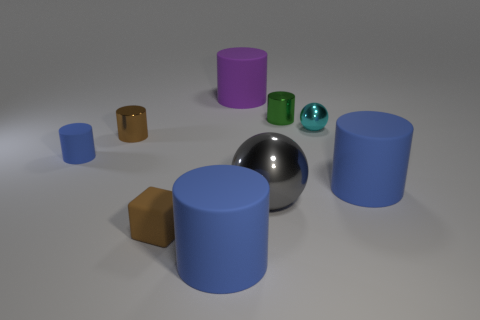Are there the same number of cylinders behind the brown rubber cube and large blue rubber objects?
Your response must be concise. No. Are there any other things that are made of the same material as the tiny blue thing?
Offer a terse response. Yes. There is a metallic cylinder that is right of the large purple matte thing; is it the same color as the metal ball behind the tiny blue thing?
Ensure brevity in your answer.  No. What number of matte cylinders are left of the green thing and on the right side of the purple thing?
Your answer should be compact. 0. How many other things are the same shape as the big purple object?
Provide a succinct answer. 5. Are there more brown metal cylinders in front of the brown cube than purple rubber things?
Your answer should be compact. No. What is the color of the matte object to the right of the green object?
Offer a very short reply. Blue. There is a object that is the same color as the tiny matte cube; what is its size?
Provide a succinct answer. Small. What number of matte objects are either purple cylinders or purple blocks?
Your answer should be compact. 1. There is a ball that is left of the tiny shiny cylinder right of the tiny brown rubber block; is there a small blue cylinder behind it?
Ensure brevity in your answer.  Yes. 